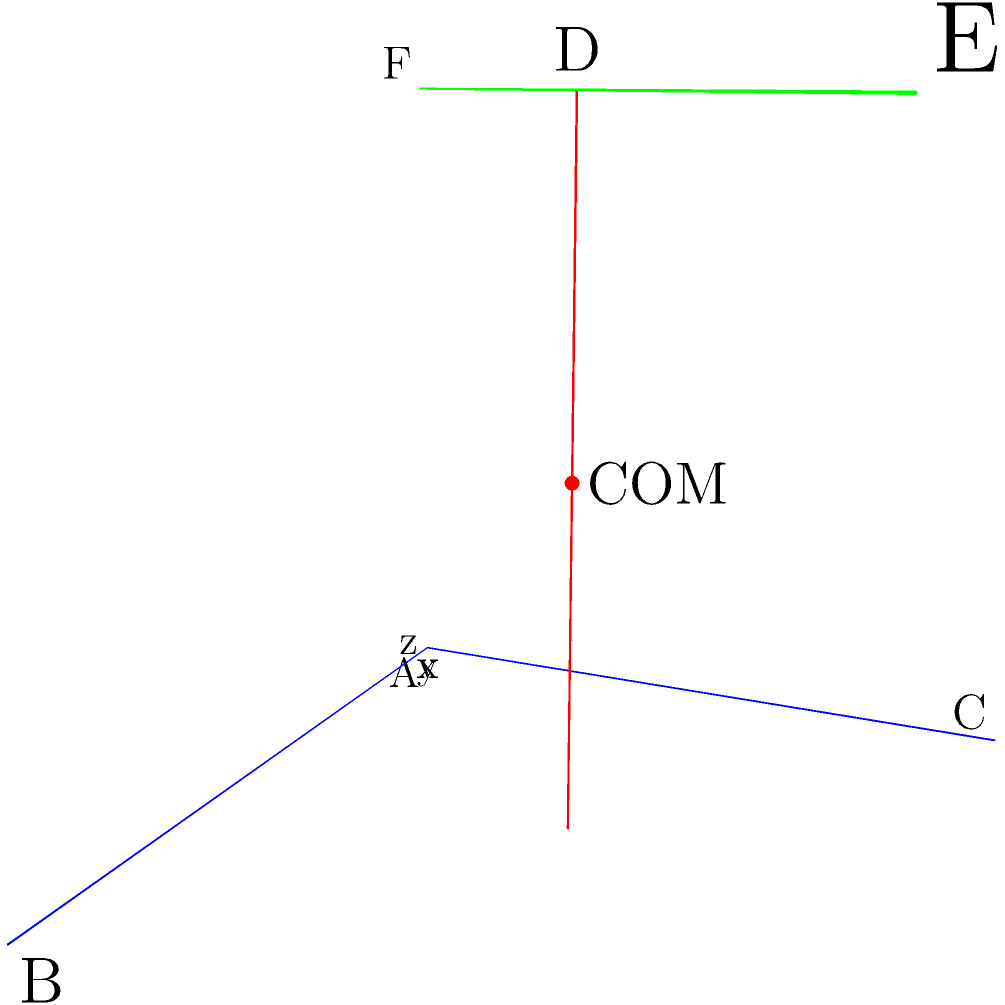An athlete is performing a complex movement, and their body segments are represented in a 3D coordinate system as follows:
- Right leg: from (0,0,0) to (1,0,0)
- Left leg: from (0,0,0) to (0,1,0)
- Torso: from (0.5,0.5,0) to (0.5,0.5,2)
- Right arm: from (0.5,0.5,2) to (1,1,2)
- Left arm: from (0.5,0.5,2) to (0,0,2)

Assuming the mass distribution is 20% for each leg, 40% for the torso, and 10% for each arm, calculate the coordinates of the athlete's center of mass (COM). To calculate the center of mass, we need to follow these steps:

1. Find the midpoint of each body segment:
   Right leg: $(\frac{0+1}{2}, \frac{0+0}{2}, \frac{0+0}{2}) = (0.5, 0, 0)$
   Left leg: $(\frac{0+0}{2}, \frac{0+1}{2}, \frac{0+0}{2}) = (0, 0.5, 0)$
   Torso: $(\frac{0.5+0.5}{2}, \frac{0.5+0.5}{2}, \frac{0+2}{2}) = (0.5, 0.5, 1)$
   Right arm: $(\frac{0.5+1}{2}, \frac{0.5+1}{2}, \frac{2+2}{2}) = (0.75, 0.75, 2)$
   Left arm: $(\frac{0.5+0}{2}, \frac{0.5+0}{2}, \frac{2+2}{2}) = (0.25, 0.25, 2)$

2. Multiply each midpoint coordinate by its corresponding mass percentage:
   Right leg: $(0.5 \times 0.2, 0 \times 0.2, 0 \times 0.2) = (0.1, 0, 0)$
   Left leg: $(0 \times 0.2, 0.5 \times 0.2, 0 \times 0.2) = (0, 0.1, 0)$
   Torso: $(0.5 \times 0.4, 0.5 \times 0.4, 1 \times 0.4) = (0.2, 0.2, 0.4)$
   Right arm: $(0.75 \times 0.1, 0.75 \times 0.1, 2 \times 0.1) = (0.075, 0.075, 0.2)$
   Left arm: $(0.25 \times 0.1, 0.25 \times 0.1, 2 \times 0.1) = (0.025, 0.025, 0.2)$

3. Sum up all the weighted coordinates:
   x-coordinate: $0.1 + 0 + 0.2 + 0.075 + 0.025 = 0.4$
   y-coordinate: $0 + 0.1 + 0.2 + 0.075 + 0.025 = 0.4$
   z-coordinate: $0 + 0 + 0.4 + 0.2 + 0.2 = 0.8$

4. The center of mass coordinates are (0.4, 0.4, 0.8).
Answer: (0.4, 0.4, 0.8) 